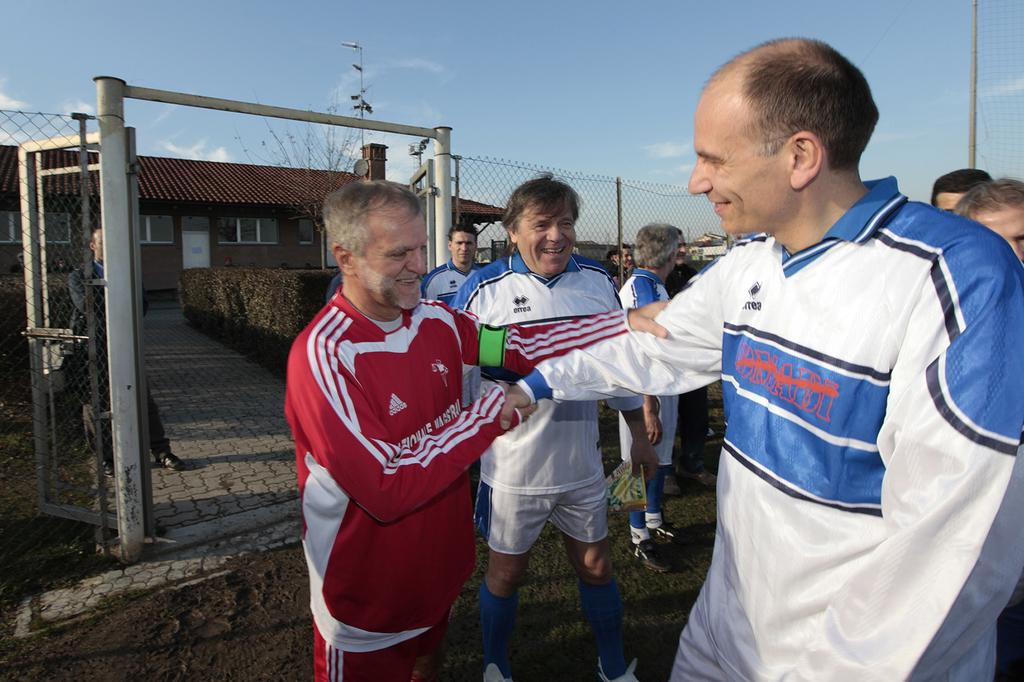<image>
Create a compact narrative representing the image presented. A man, wearing a red Adidas jacket, shakes hands with another man. 